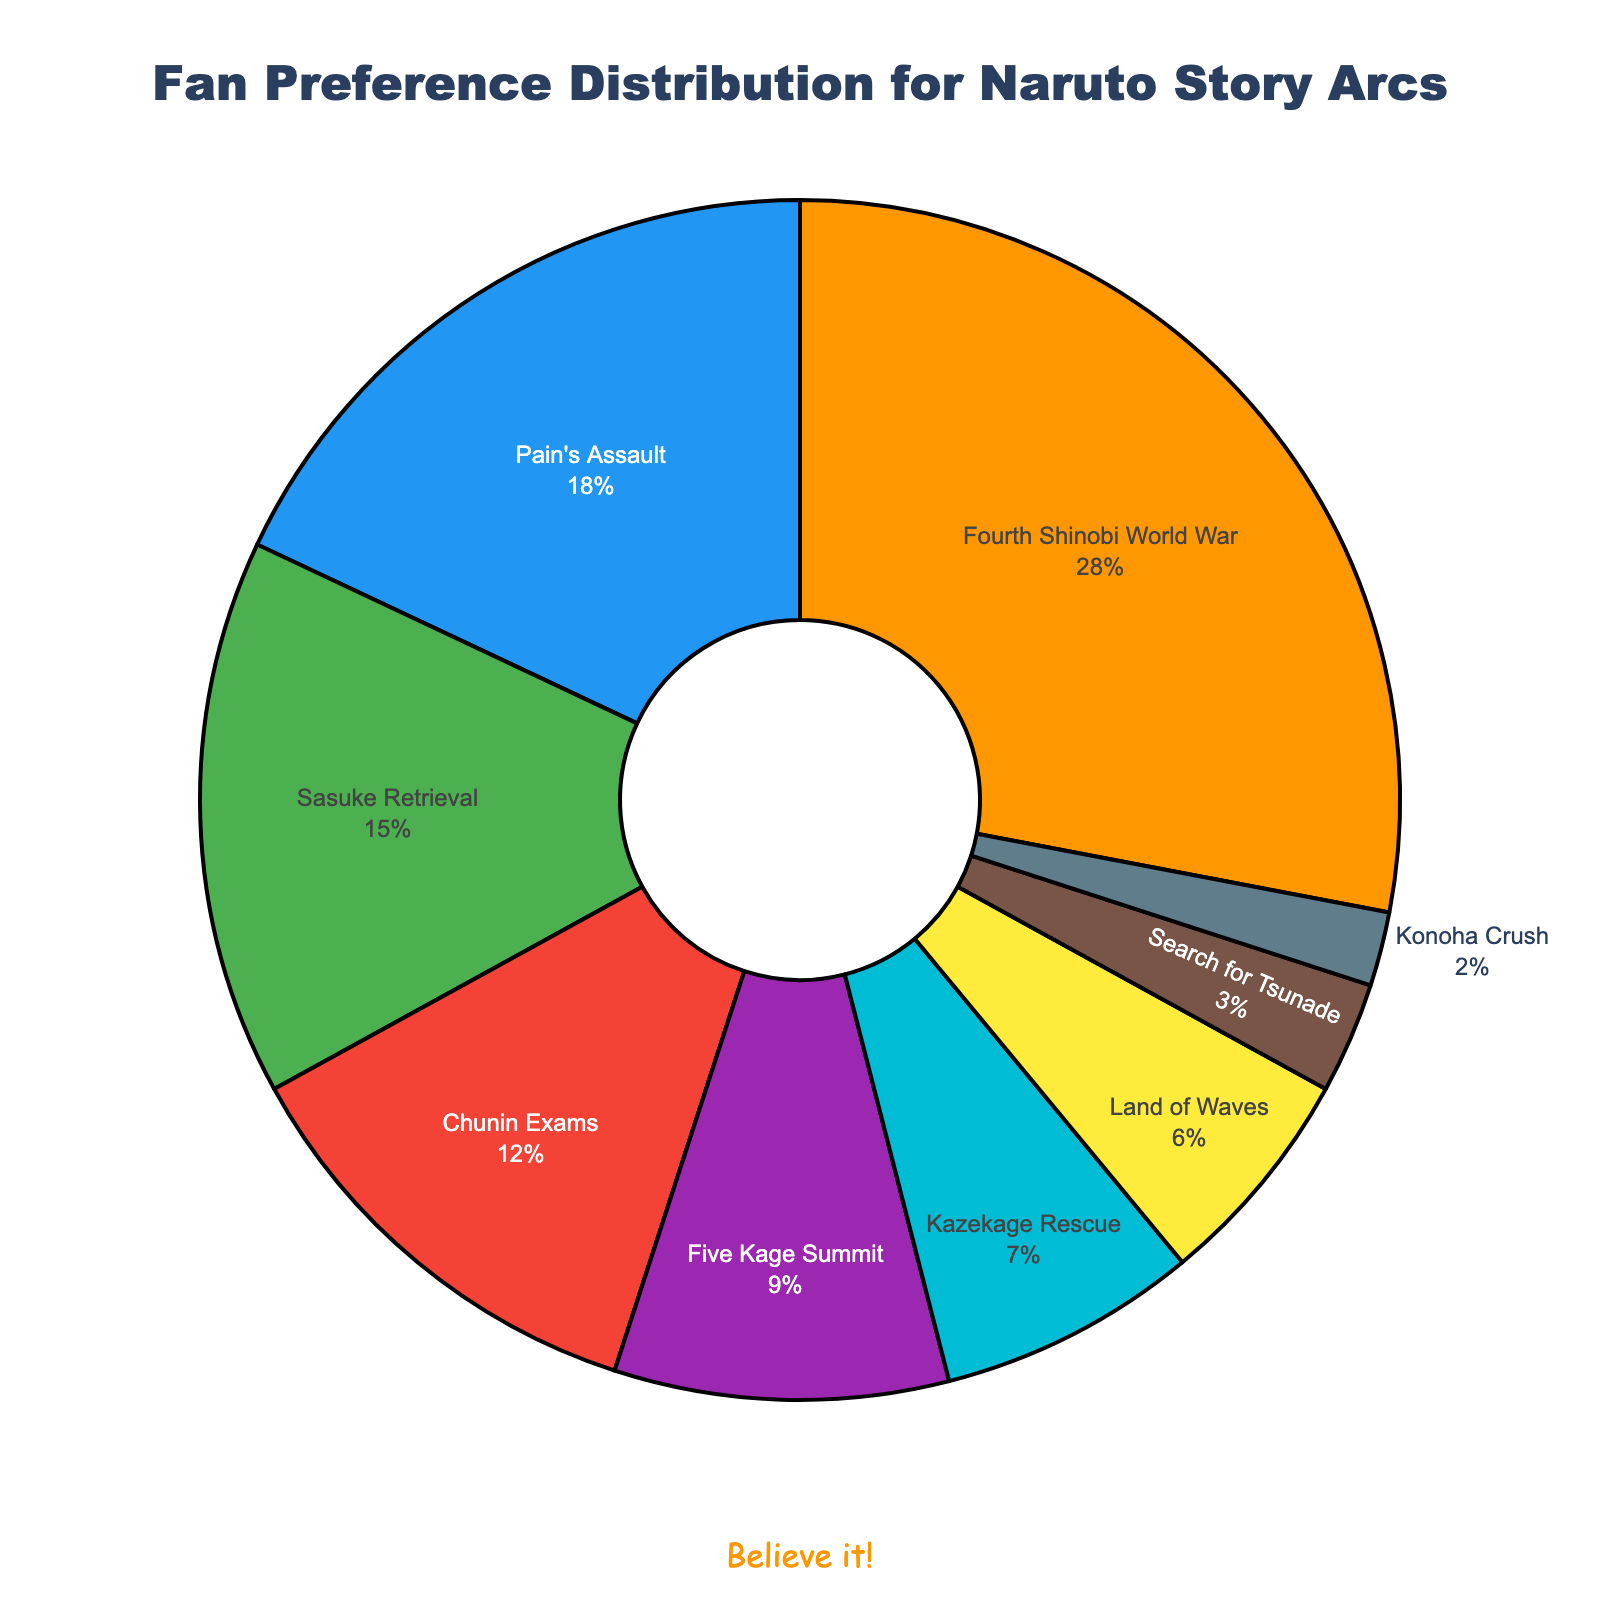What's the most preferred story arc among fans? The pie chart shows that the "Fourth Shinobi World War" arc has the highest percentage at 28%, indicating it is the most preferred arc among fans.
Answer: Fourth Shinobi World War Which story arc has the least preference among fans? The pie chart reveals that the "Konoha Crush" arc has the smallest segment, with only 2% of the total fan preference, making it the least preferred arc.
Answer: Konoha Crush Compare the percentages of fan preference between "Pain's Assault" and "Sasuke Retrieval" arcs. Which one has a higher preference? According to the pie chart, "Pain's Assault" has 18% while "Sasuke Retrieval" has 15%. Therefore, "Pain's Assault" has a higher preference.
Answer: Pain's Assault Sum the percentages of the three most preferred story arcs. The three most preferred arcs are "Fourth Shinobi World War" (28%), "Pain's Assault" (18%), and "Sasuke Retrieval" (15%). Summing these gives 28 + 18 + 15 = 61%.
Answer: 61% What is the combined preference percentage for the "Land of Waves" and "Search for Tsunade" arcs? The "Land of Waves" arc has 6% and the "Search for Tsunade" arc has 3%. Adding these together gives 6 + 3 = 9%.
Answer: 9% Which arc has more fan preference: "Chunin Exams" or "Five Kage Summit"? The pie chart shows that "Chunin Exams" has 12%, while "Five Kage Summit" has 9%. Thus, "Chunin Exams" has more fan preference.
Answer: Chunin Exams What is the difference in preference percentage between the "Kazekage Rescue" and "Konoha Crush" arcs? "Kazekage Rescue" has 7% and "Konoha Crush" has 2%. The difference is 7 - 2 = 5%.
Answer: 5% What percentage of fans prefer arcs other than "Fourth Shinobi World War"? The total percentage is 100%. Subtracting the "Fourth Shinobi World War" preference (28%), we get 100 - 28 = 72%.
Answer: 72% Which arcs collectively hold more than 50% fan preference? "Fourth Shinobi World War" (28%), "Pain's Assault" (18%), and "Sasuke Retrieval" (15%). Together they make up 28 + 18 + 15 = 61%, which is more than 50%.
Answer: Fourth Shinobi World War, Pain's Assault, Sasuke Retrieval 